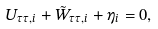Convert formula to latex. <formula><loc_0><loc_0><loc_500><loc_500>U _ { \tau \tau , i } + \tilde { W } _ { \tau \tau , i } + \eta _ { i } = 0 ,</formula> 